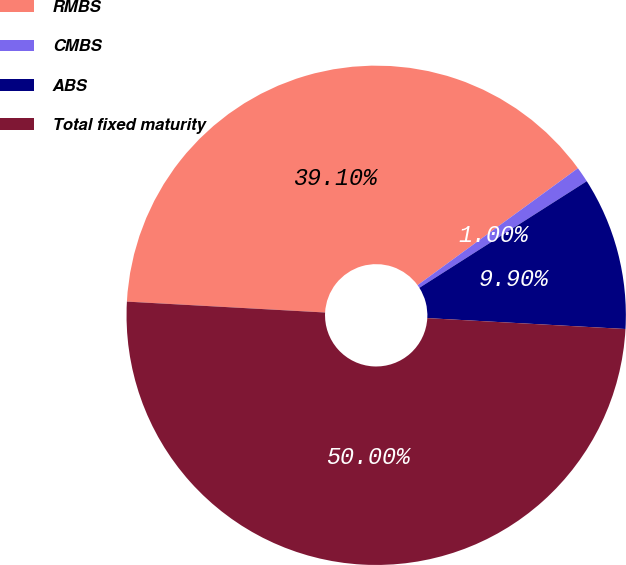Convert chart. <chart><loc_0><loc_0><loc_500><loc_500><pie_chart><fcel>RMBS<fcel>CMBS<fcel>ABS<fcel>Total fixed maturity<nl><fcel>39.1%<fcel>1.0%<fcel>9.9%<fcel>50.0%<nl></chart> 